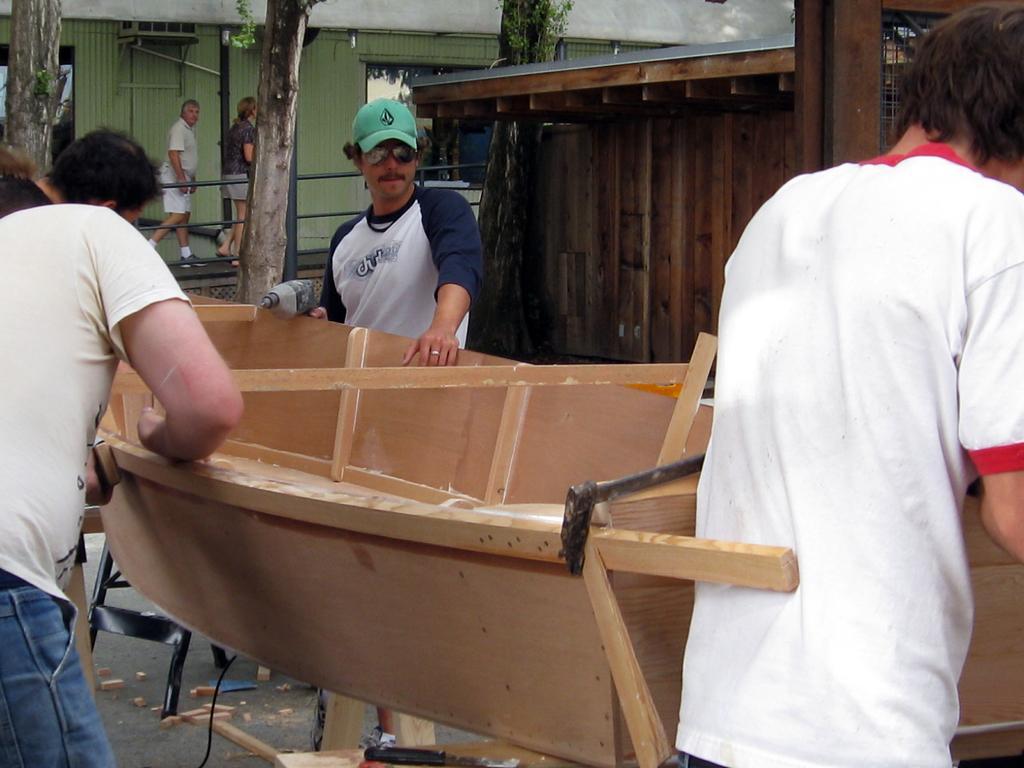Could you give a brief overview of what you see in this image? In this image I can see few people are standing in the front. I can also see one of them is holding a drill machine and I can see he is wearing shades, t shirt and a cap. In the background I can see a building, few tree trunks and few more people are standing. 